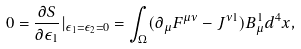Convert formula to latex. <formula><loc_0><loc_0><loc_500><loc_500>0 = \frac { \partial S } { \partial \epsilon _ { 1 } } | _ { \epsilon _ { 1 } = \epsilon _ { 2 } = 0 } = \int _ { \Omega } ( \partial _ { \mu } F ^ { \mu \nu } - J ^ { \nu 1 } ) B _ { \mu } ^ { 1 } d ^ { 4 } x ,</formula> 